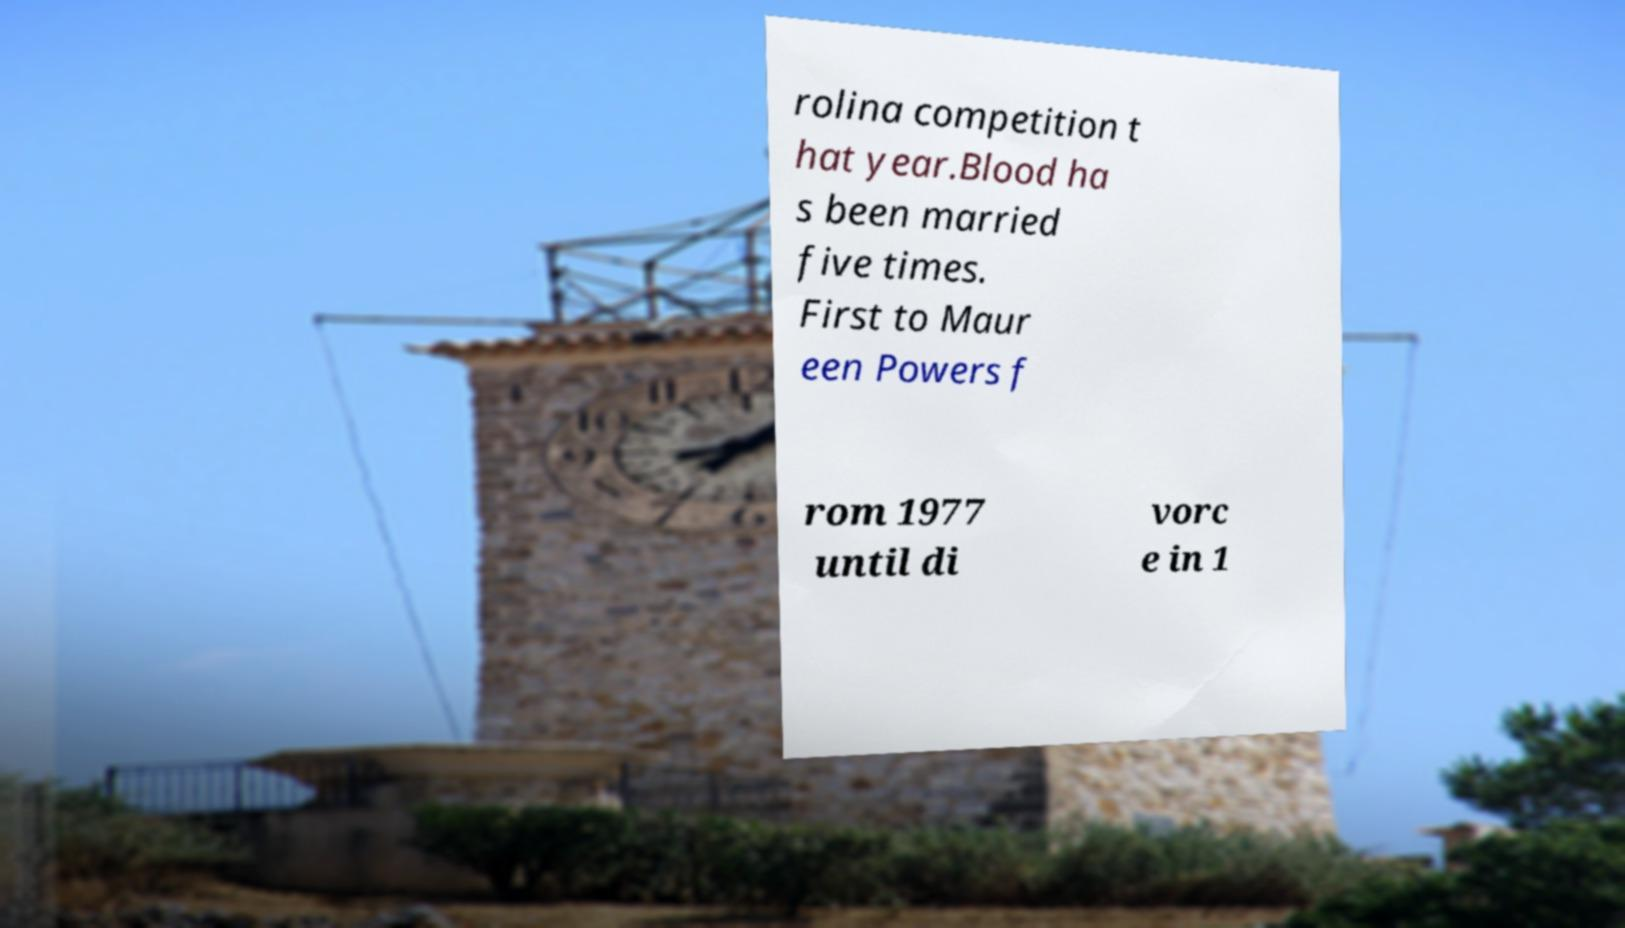Could you extract and type out the text from this image? rolina competition t hat year.Blood ha s been married five times. First to Maur een Powers f rom 1977 until di vorc e in 1 